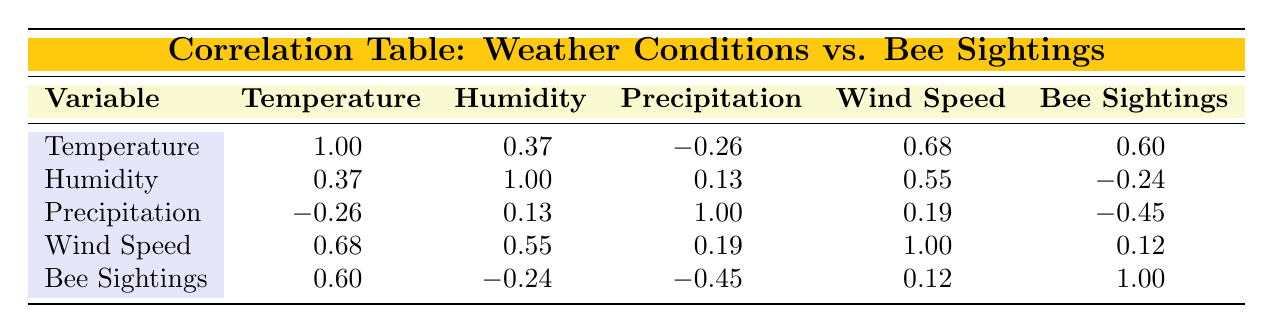What is the correlation between temperature and bee sightings? The correlation value between temperature and bee sightings is 0.60, as indicated in the table. This means there is a positive correlation, suggesting that higher temperatures are associated with more bee sightings.
Answer: 0.60 What is the correlation between humidity and bee sightings? The correlation value between humidity and bee sightings is -0.24, showing a negative correlation. This indicates that as humidity increases, the frequency of bee sightings tends to decrease.
Answer: -0.24 Is there a strong correlation between wind speed and temperature? The correlation value between wind speed and temperature is 0.68, which indicates a strong positive correlation. This suggests that as wind speed increases, temperature also tends to increase.
Answer: Yes What is the average correlation value among all pairs with bee sightings? To find the average, we take the correlation values associated with bee sightings: 0.60, -0.24, -0.45, and 0.12. Summing these gives 0.60 + (-0.24) + (-0.45) + 0.12 = -0.03, then dividing by 4 data points: -0.03/4 = -0.0075.
Answer: -0.0075 Do higher precipitation levels correlate with fewer bee sightings? The correlation value between precipitation and bee sightings is -0.45, which indicates a negative correlation. This suggests that higher levels of precipitation are indeed associated with fewer bee sightings.
Answer: Yes What is the relationship between wind speed and bee sightings? The correlation value between wind speed and bee sightings is 0.12. This indicates a weak positive correlation, suggesting that changes in wind speed do not significantly affect bee sightings.
Answer: 0.12 What is the difference between the correlation values of wind speed and humidity? The correlation value for wind speed is 0.12 and for humidity, it is -0.24. The difference is calculated as 0.12 - (-0.24) = 0.12 + 0.24 = 0.36.
Answer: 0.36 Is temperature more positively correlated with bee sightings than wind speed? The correlation of temperature with bee sightings is 0.60, and for wind speed, it is 0.12. Since 0.60 is greater than 0.12, temperature is indeed more positively correlated with bee sightings than wind speed.
Answer: Yes 